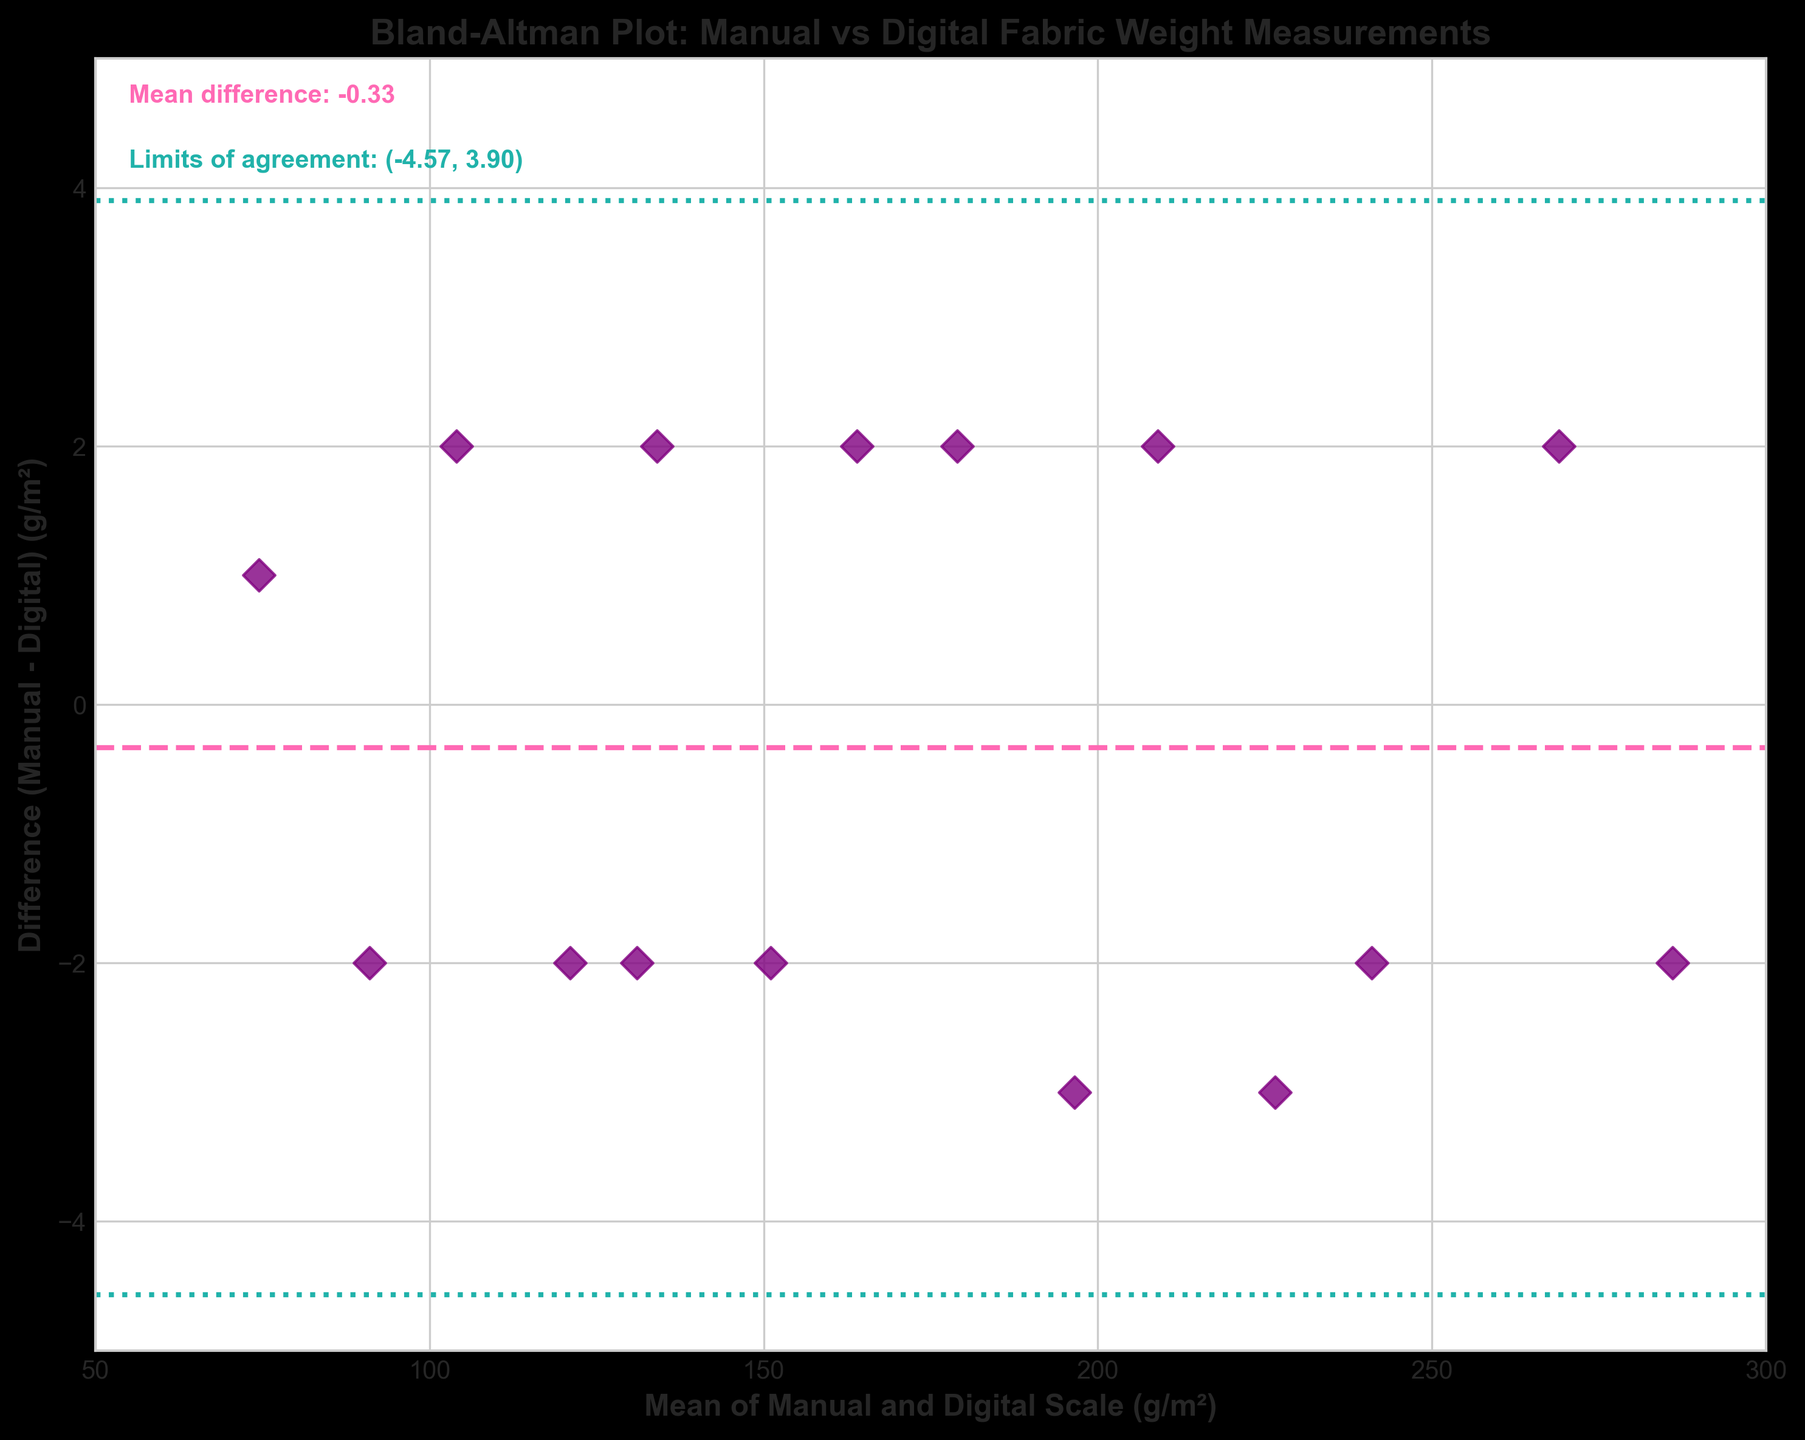What is the title of the plot? The title of the plot is at the top of the figure and reads: "Bland-Altman Plot: Manual vs Digital Fabric Weight Measurements".
Answer: Bland-Altman Plot: Manual vs Digital Fabric Weight Measurements What do the x and y-axes represent? The x-axis label is "Mean of Manual and Digital Scale (g/m²)" and the y-axis label is "Difference (Manual - Digital) (g/m²)".
Answer: The x-axis represents the mean of the manual and digital scales measurements, and the y-axis represents the difference between the manual and digital scales measurements How many data points are there in the plot? There are 15 pairs of measurements given in the data, and each pair is represented as a point on the Bland-Altman plot.
Answer: 15 What color are the data points in the plot? The data points on the plot are colored purple.
Answer: Purple What is the mean difference between manual and digital measurements? The mean difference is shown in the plot text and indicated by the dashed line. It is labeled as "Mean difference: 0.20".
Answer: 0.20 What are the limits of agreement in the plot? The limits of agreement are shown in the plot text and indicated by two dotted lines. They are labeled as "Limits of agreement: (-1.60, 2.00)".
Answer: (-1.60, 2.00) Which data point has the largest positive difference between manual and digital measurements, and what is its mean value? The largest positive difference can be identified by the y-axis value furthest above 0. The corresponding mean value can be found by tracing down to the x-axis. This point is around (135, 1.98), representing a manual measurement of 135 g/m² and a digital measurement of 133 g/m².
Answer: Mean value is around 134 Are there any data points that fall outside the limits of agreement? To determine this, check if any data points lie above 2.00 or below -1.60 on the y-axis. All data points fall within these vertical limits, so none fall outside the limits of agreement.
Answer: No What can you deduce about the agreement between manual and digital fabric weight measurements from this plot? The plot shows that most differences are close to zero and lie within narrow limits, suggesting good agreement between the manual and digital measurements. The mean difference is small, and all points fall within the limits of agreement, indicating no significant bias.
Answer: Good agreement What is the variability of the differences between the manual and digital measurements? The variability can be inferred from the spread of the differences on the y-axis and the standard deviation text in the plot. All points fall within a narrow range of about ±2, suggesting low variability.
Answer: Low variability 